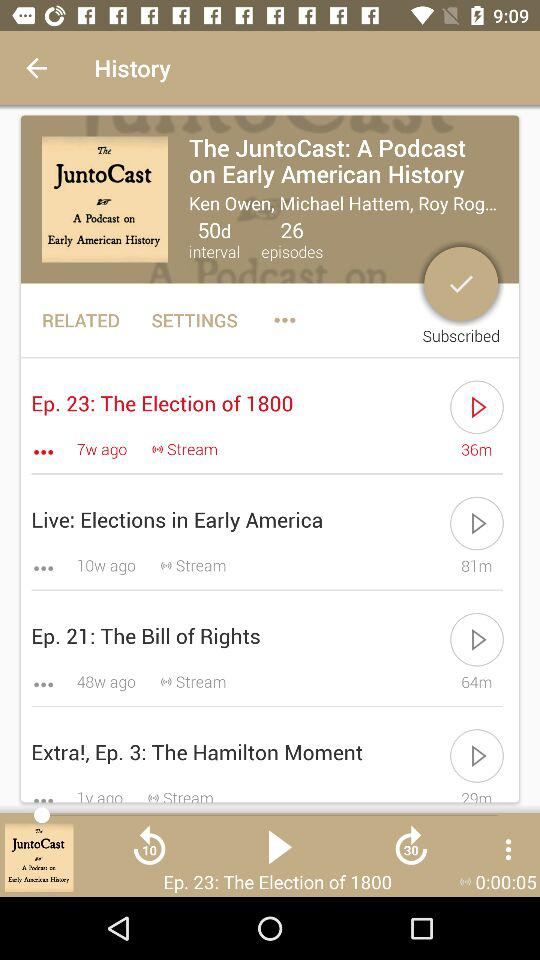How long is Episode 23? Episode 23 is 36 minutes long. 